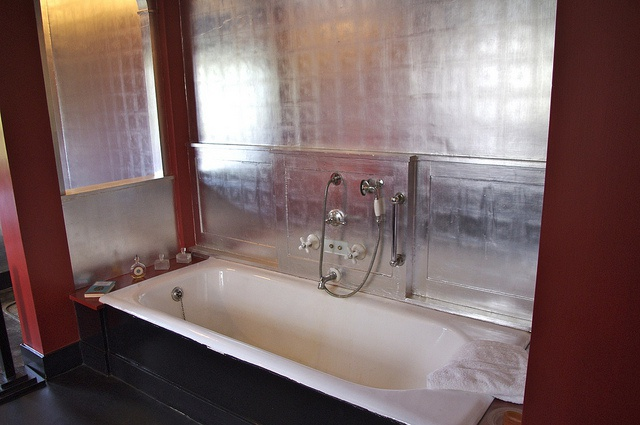Describe the objects in this image and their specific colors. I can see a book in black, gray, maroon, and tan tones in this image. 